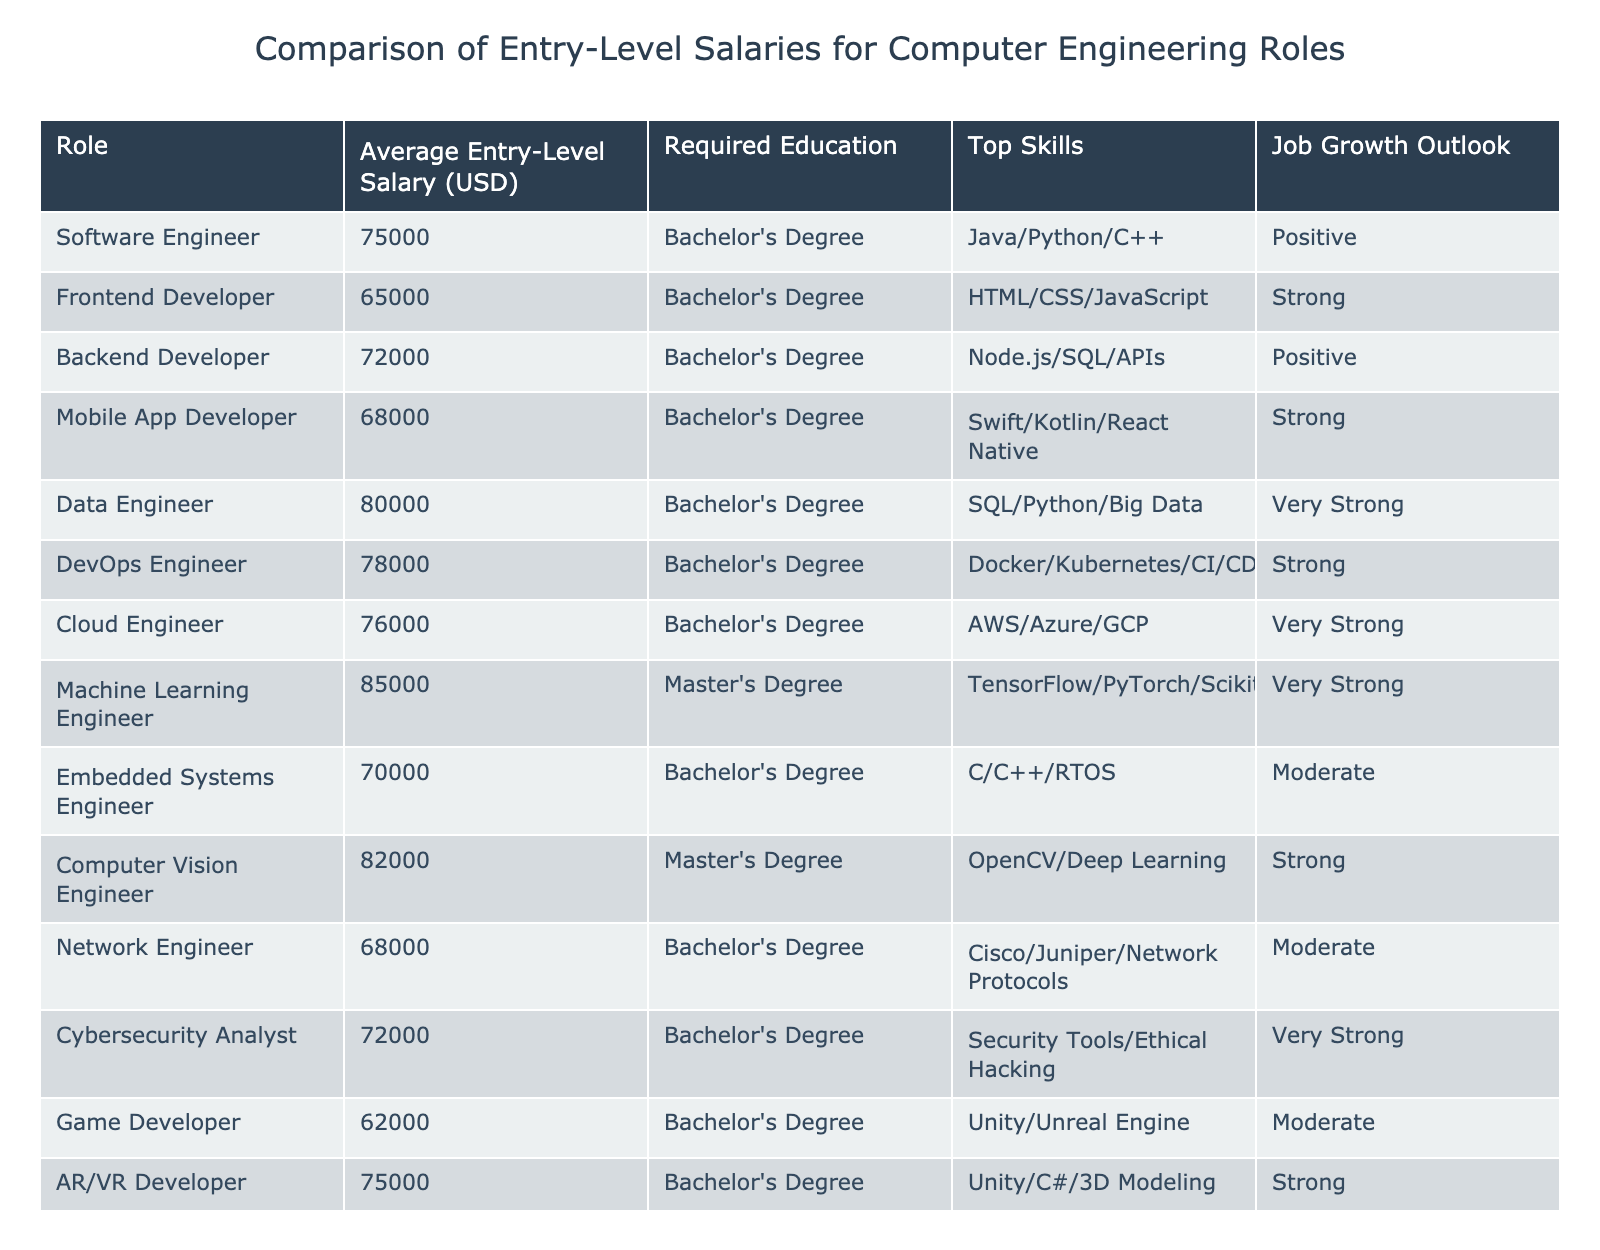What is the average entry-level salary for a Data Engineer? According to the table, the average entry-level salary for a Data Engineer is listed as 80,000 USD.
Answer: 80,000 USD Which role requires a Master's Degree? The table indicates that the Machine Learning Engineer and Computer Vision Engineer roles require a Master's Degree.
Answer: Machine Learning Engineer and Computer Vision Engineer What is the difference in average salary between a Software Engineer and a Game Developer? The average salary for a Software Engineer is 75,000 USD, and for a Game Developer, it is 62,000 USD. The difference is 75,000 - 62,000 = 13,000 USD.
Answer: 13,000 USD Which role has the highest average entry-level salary and what is that salary? The table shows that the Machine Learning Engineer has the highest average entry-level salary of 85,000 USD.
Answer: Machine Learning Engineer, 85,000 USD Is the job growth outlook for Cloud Engineers classified as strong? The job growth outlook for Cloud Engineers in the table is categorized as "Very Strong," so it is not classified as simply "Strong."
Answer: No How many roles have a positive job growth outlook? Looking at the table, the roles with a positive job growth outlook are Software Engineer, Backend Developer, Blockchain Developer, and others. Counting these, there are 4 roles with a positive outlook.
Answer: 4 What is the average salary of all roles that require a Master's Degree? The roles requiring a Master's Degree are Machine Learning Engineer (85,000 USD) and Computer Vision Engineer (82,000 USD). The average is (85,000 + 82,000) / 2 = 83,500 USD.
Answer: 83,500 USD Which role has the lowest average entry-level salary, and what is that salary? The lowest average entry-level salary is for the Game Developer role, which is 62,000 USD.
Answer: Game Developer, 62,000 USD Identify all roles with an average salary above 75,000 USD. The roles with average salaries above 75,000 USD are Software Engineer (75,000), Data Engineer (80,000), Cloud Engineer (76,000), DevOps Engineer (78,000), Machine Learning Engineer (85,000), and Computer Vision Engineer (82,000).
Answer: Software Engineer, Data Engineer, Cloud Engineer, DevOps Engineer, Machine Learning Engineer, Computer Vision Engineer What is the combined average salary of Frontend and Backend Developers? The average salary for Frontend Developers is 65,000 USD and for Backend Developers, it is 72,000 USD. The combined average is (65,000 + 72,000) / 2 = 68,500 USD.
Answer: 68,500 USD 